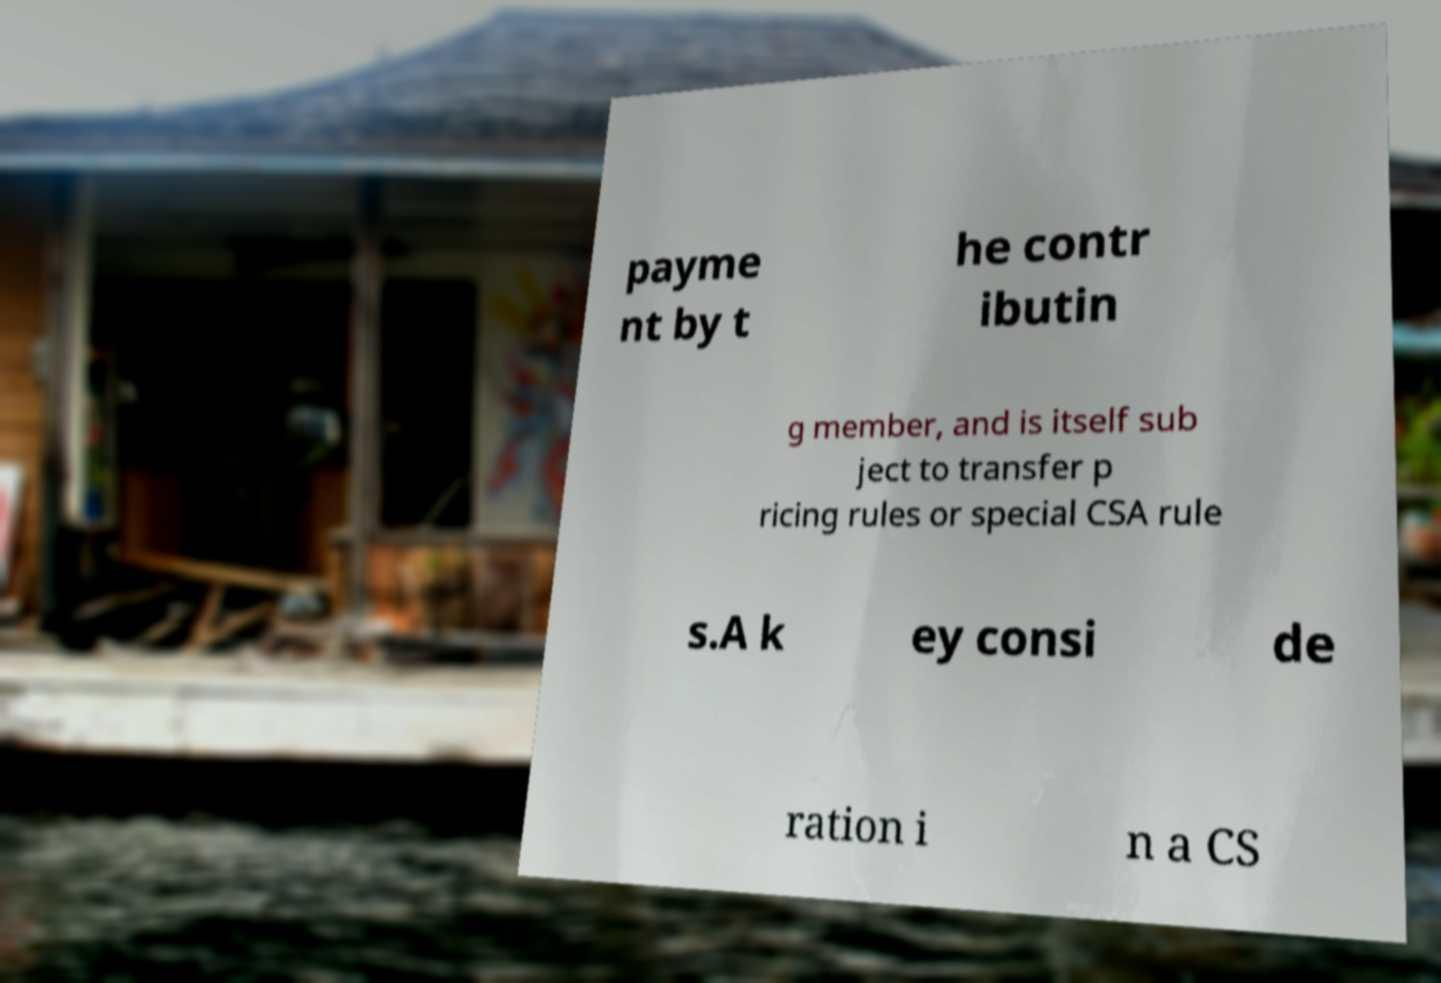Please identify and transcribe the text found in this image. payme nt by t he contr ibutin g member, and is itself sub ject to transfer p ricing rules or special CSA rule s.A k ey consi de ration i n a CS 